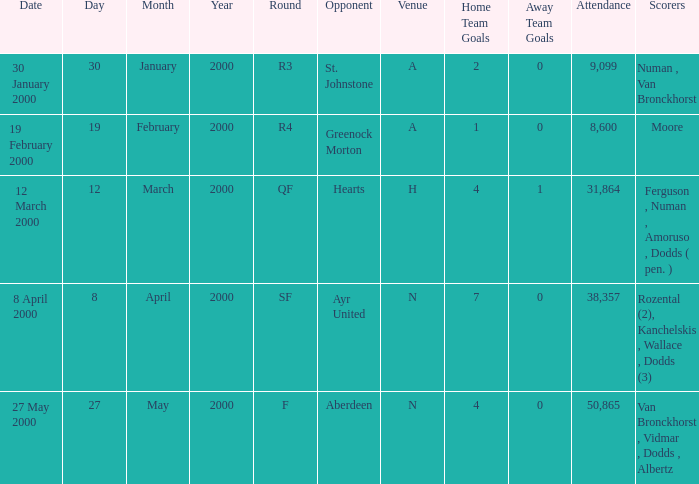What venue was on 27 May 2000? N. 